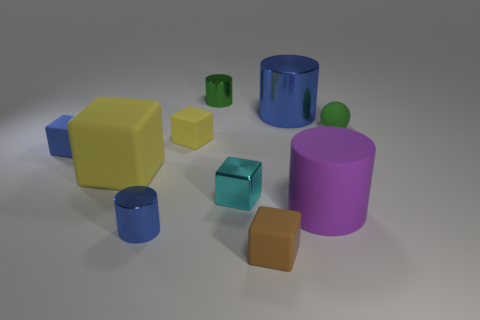Is the shape of the big blue object the same as the blue rubber object that is left of the small blue metallic cylinder?
Offer a very short reply. No. How many other objects are the same material as the brown object?
Your answer should be compact. 5. Do the tiny rubber ball and the big rubber thing that is on the left side of the green metal thing have the same color?
Your answer should be compact. No. What material is the tiny green thing on the right side of the small brown matte cube?
Provide a short and direct response. Rubber. Are there any large shiny objects of the same color as the small shiny block?
Give a very brief answer. No. There is a metallic block that is the same size as the green rubber ball; what is its color?
Give a very brief answer. Cyan. What number of large things are either green matte objects or brown rubber blocks?
Give a very brief answer. 0. Are there the same number of tiny brown rubber things that are behind the small brown object and small cubes on the right side of the green sphere?
Your answer should be compact. Yes. What number of purple rubber objects are the same size as the cyan shiny cube?
Keep it short and to the point. 0. What number of gray objects are tiny rubber blocks or shiny things?
Your answer should be compact. 0. 